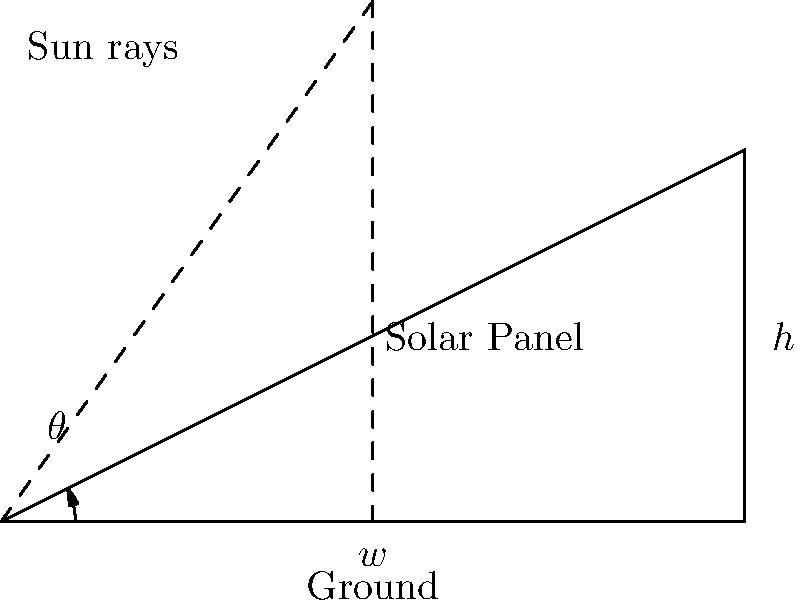You are designing a smart building with solar panels on the roof. The building's width is 100 meters, and you want to determine the optimal angle for the solar panels to maximize energy efficiency. If the height of the solar panel array at its highest point is 50 meters, what is the optimal angle $\theta$ (in degrees) for the solar panels with respect to the horizontal roof? To find the optimal angle for the solar panels, we need to use trigonometry. Let's approach this step-by-step:

1) In the diagram, we have a right-angled triangle where:
   - The base (width of the building) is 100 meters (w)
   - The height of the solar panel array is 50 meters (h)

2) We need to find the angle $\theta$ between the horizontal roof and the solar panel.

3) In a right-angled triangle, we can use the tangent function to find this angle:

   $$\tan(\theta) = \frac{\text{opposite}}{\text{adjacent}} = \frac{h}{w}$$

4) Substituting our known values:

   $$\tan(\theta) = \frac{50}{100} = 0.5$$

5) To find $\theta$, we need to use the inverse tangent function (arctan or $\tan^{-1}$):

   $$\theta = \tan^{-1}(0.5)$$

6) Using a calculator or trigonometric tables:

   $$\theta \approx 26.57^\circ$$

7) Rounding to two decimal places:

   $$\theta \approx 26.57^\circ$$

This angle will provide the optimal positioning for the solar panels to maximize energy efficiency based on the given dimensions.
Answer: $26.57^\circ$ 